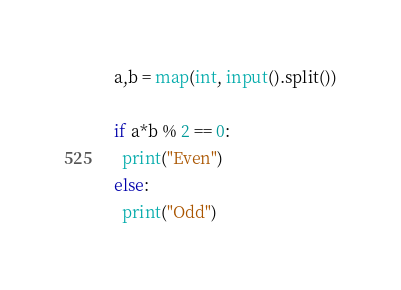Convert code to text. <code><loc_0><loc_0><loc_500><loc_500><_Python_>a,b = map(int, input().split())

if a*b % 2 == 0:
  print("Even")
else:
  print("Odd")</code> 